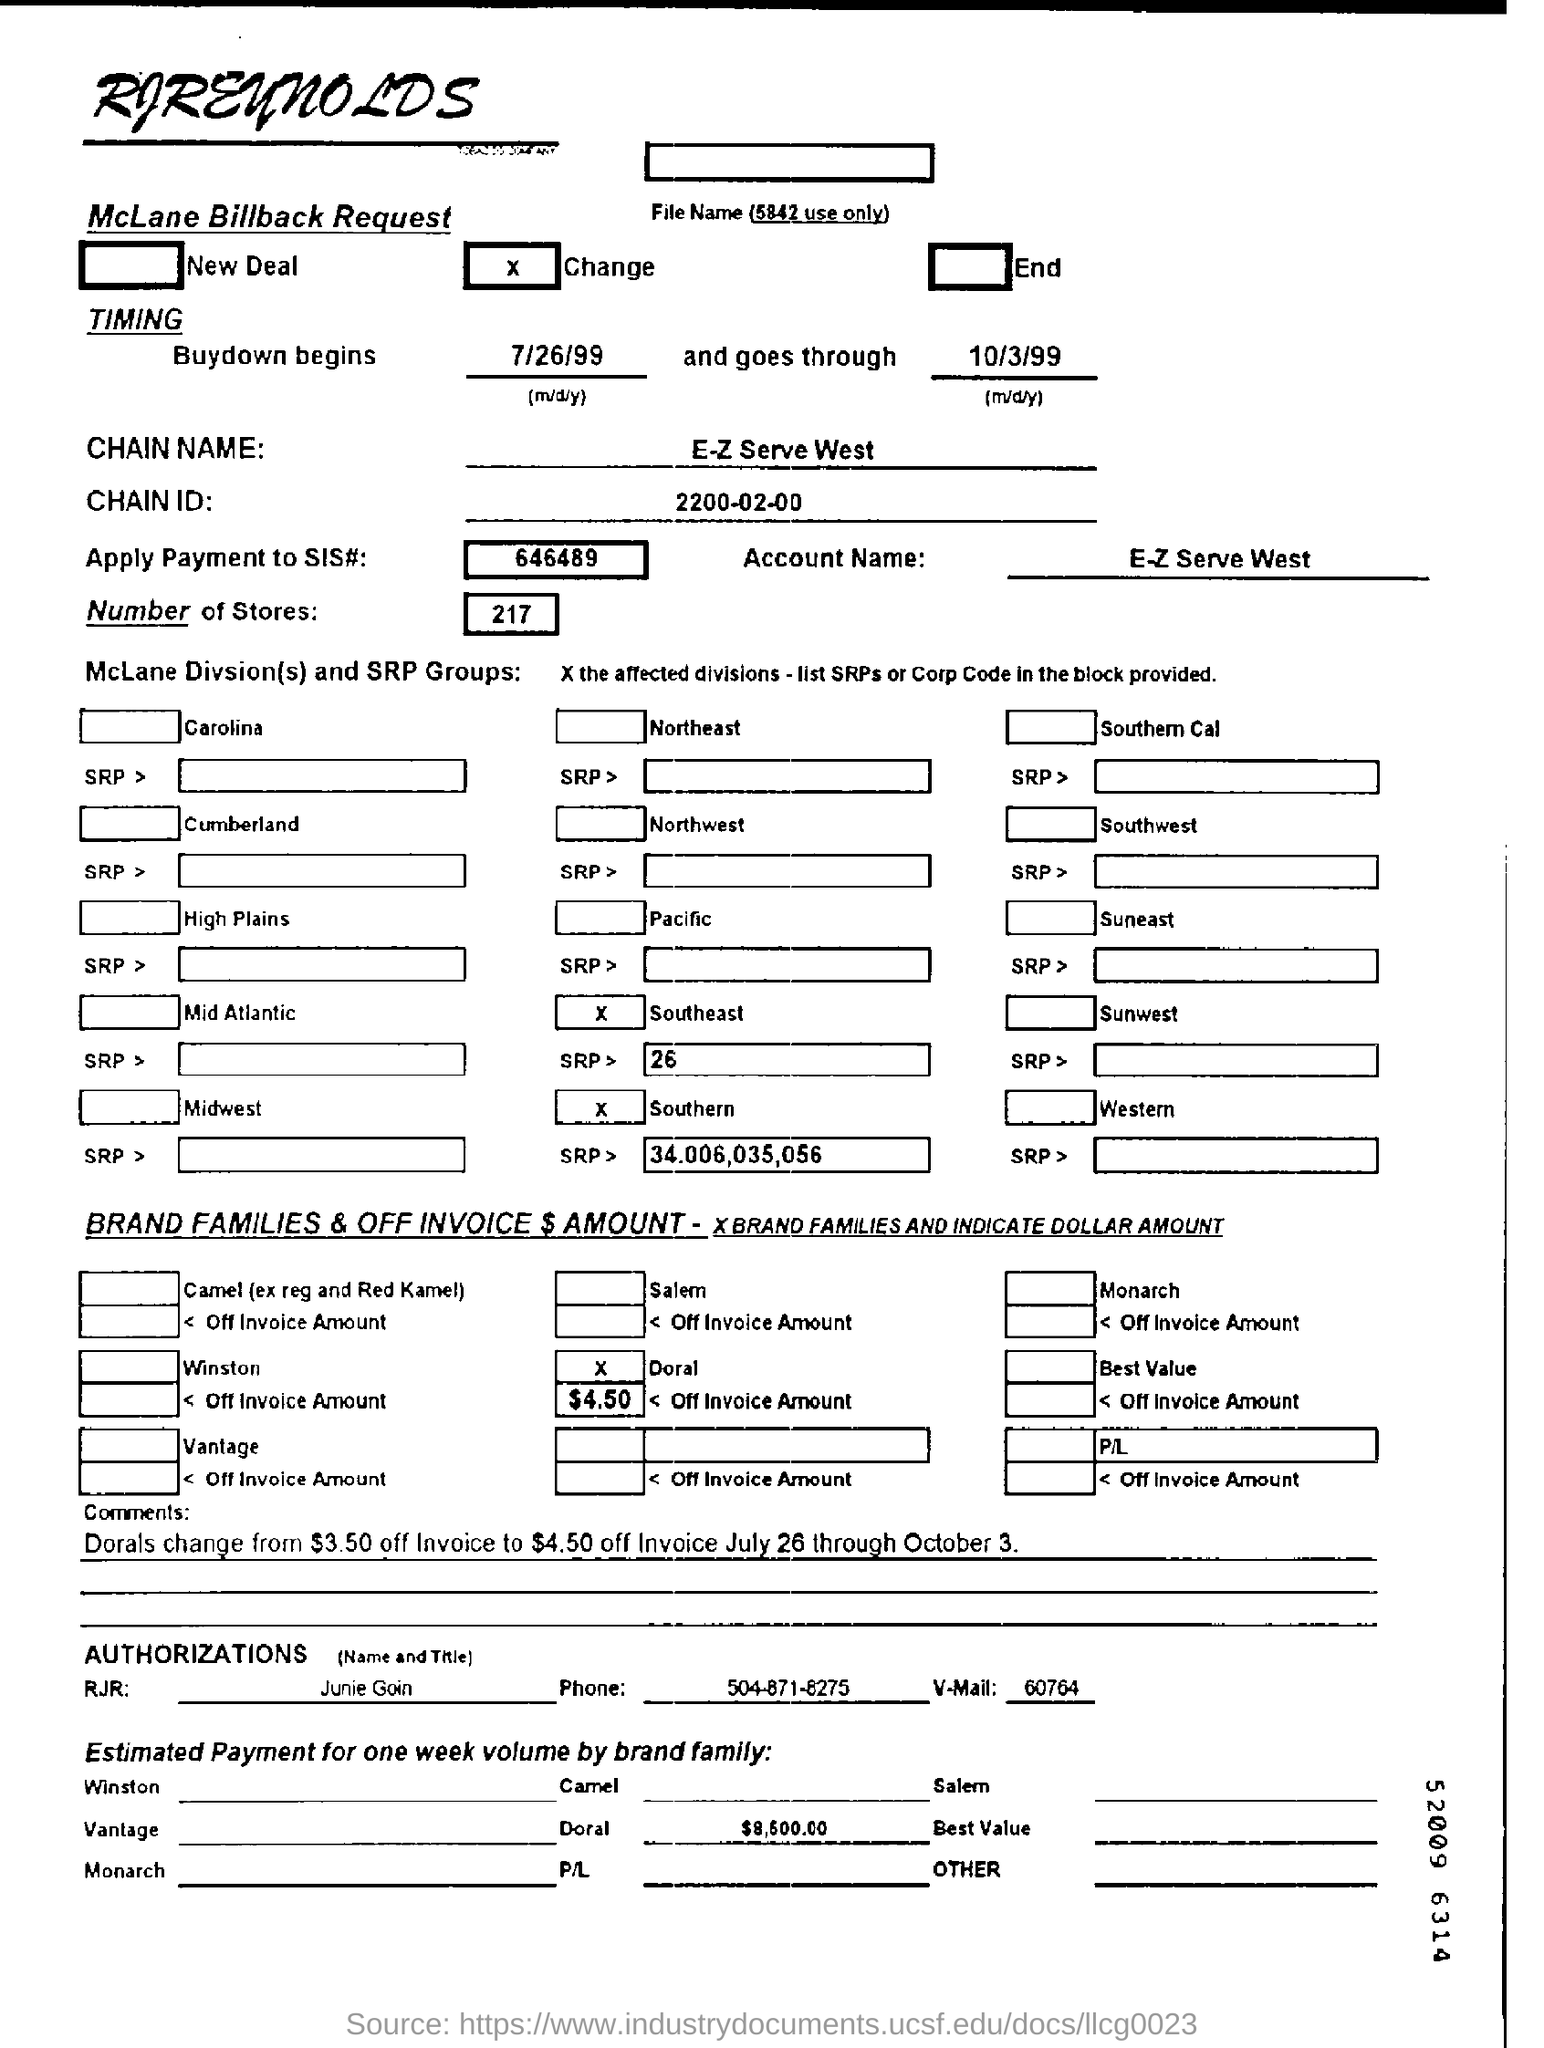Highlight a few significant elements in this photo. The name of the chain is E-Z Serve West. The buydown will commence on July 26, 1999. There are 217 stores mentioned on the McLane billback request form. The estimated payment for one week's volume by Doral Family is approximately $8,600.00. 